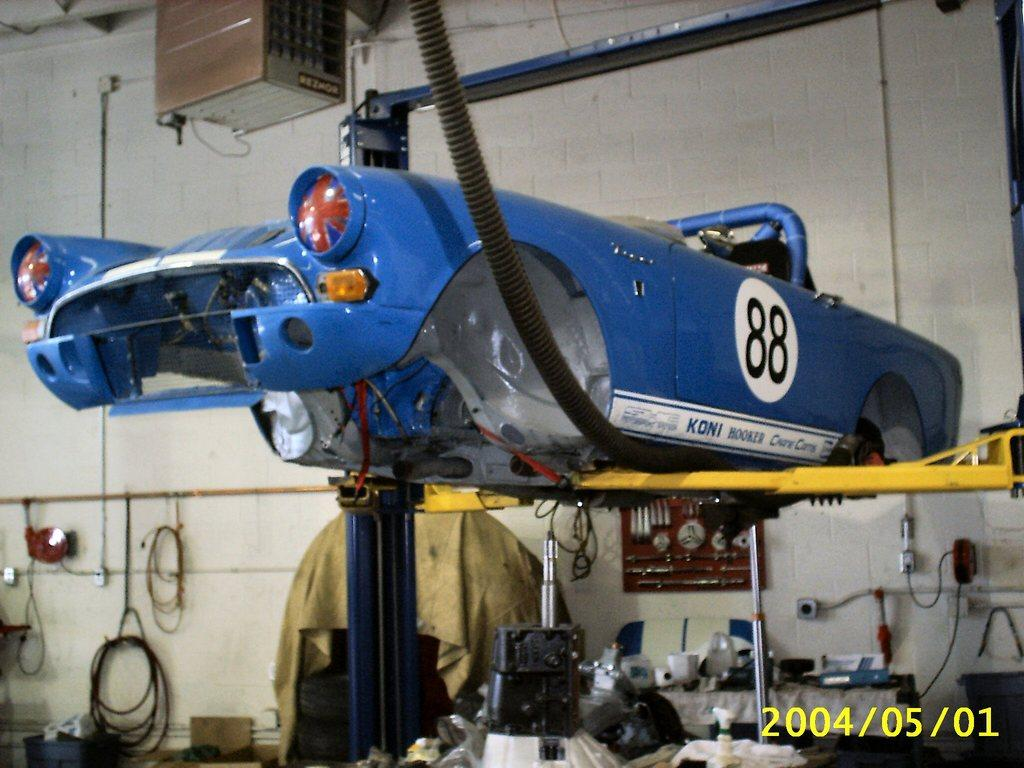<image>
Offer a succinct explanation of the picture presented. The number 88 is on the side of a blue car. 